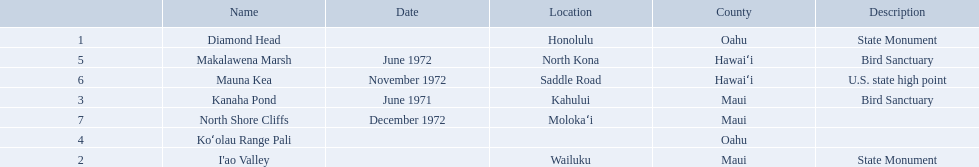What are the national natural landmarks in hawaii? Diamond Head, I'ao Valley, Kanaha Pond, Koʻolau Range Pali, Makalawena Marsh, Mauna Kea, North Shore Cliffs. Which of theses are in hawa'i county? Makalawena Marsh, Mauna Kea. Of these which has a bird sanctuary? Makalawena Marsh. What are the natural landmarks in hawaii(national)? Diamond Head, I'ao Valley, Kanaha Pond, Koʻolau Range Pali, Makalawena Marsh, Mauna Kea, North Shore Cliffs. Of these which is described as a u.s state high point? Mauna Kea. What are all of the landmark names in hawaii? Diamond Head, I'ao Valley, Kanaha Pond, Koʻolau Range Pali, Makalawena Marsh, Mauna Kea, North Shore Cliffs. What are their descriptions? State Monument, State Monument, Bird Sanctuary, , Bird Sanctuary, U.S. state high point, . And which is described as a u.s. state high point? Mauna Kea. 